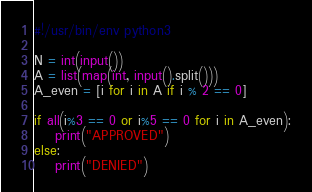Convert code to text. <code><loc_0><loc_0><loc_500><loc_500><_Python_>#!/usr/bin/env python3

N = int(input())
A = list(map(int, input().split()))
A_even = [i for i in A if i % 2 == 0]

if all(i%3 == 0 or i%5 == 0 for i in A_even):
    print("APPROVED")
else:
    print("DENIED")</code> 